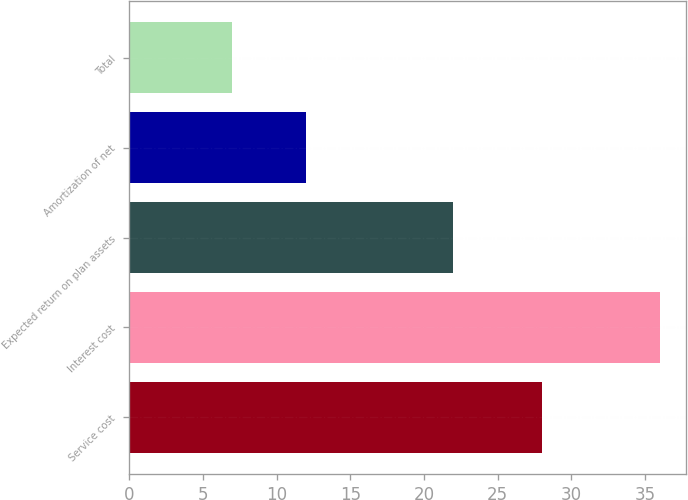Convert chart. <chart><loc_0><loc_0><loc_500><loc_500><bar_chart><fcel>Service cost<fcel>Interest cost<fcel>Expected return on plan assets<fcel>Amortization of net<fcel>Total<nl><fcel>28<fcel>36<fcel>22<fcel>12<fcel>7<nl></chart> 